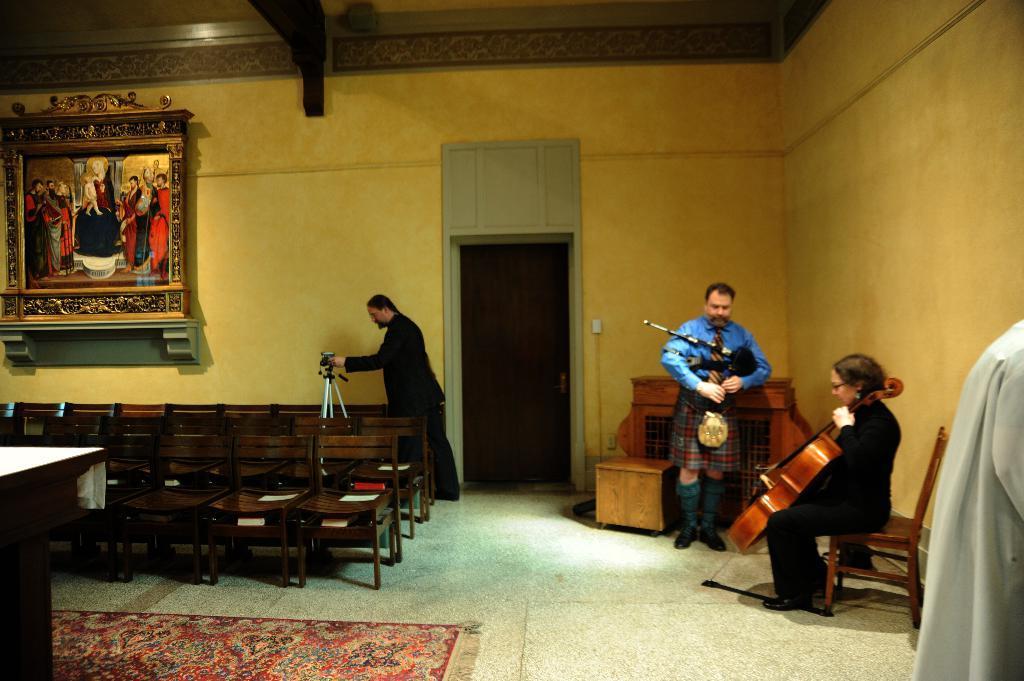Can you describe this image briefly? In this picture we can see four people and couple of chairs, in the right side of the image a woman seated on the chair and playing violin and next to her there is a man he is standing and playing some music instrument in the middle of the image one man is trying to operate camera in the background we can find a wall painting. 